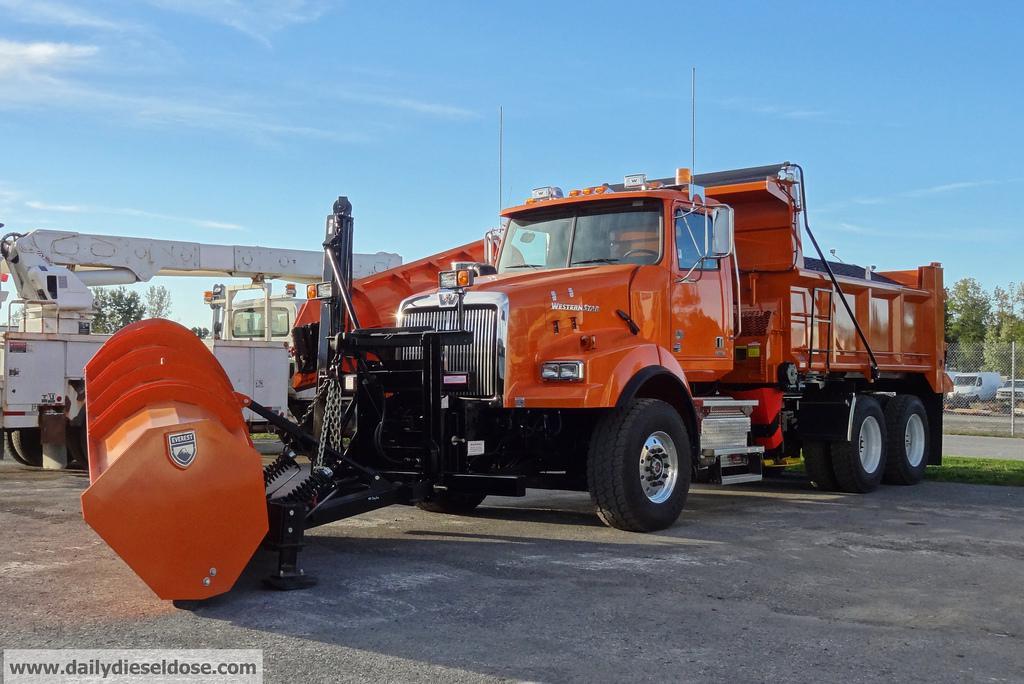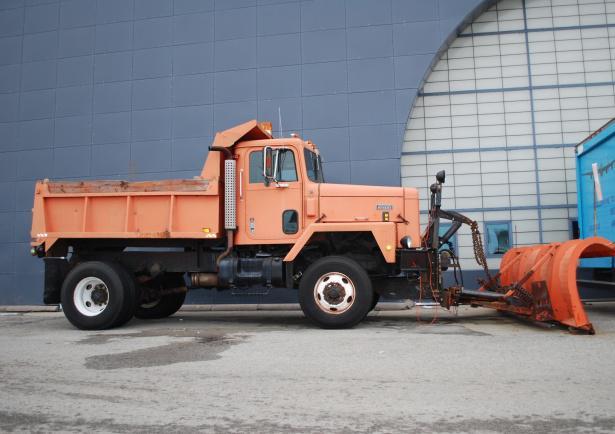The first image is the image on the left, the second image is the image on the right. For the images displayed, is the sentence "There is a snowplow plowing snow." factually correct? Answer yes or no. No. 